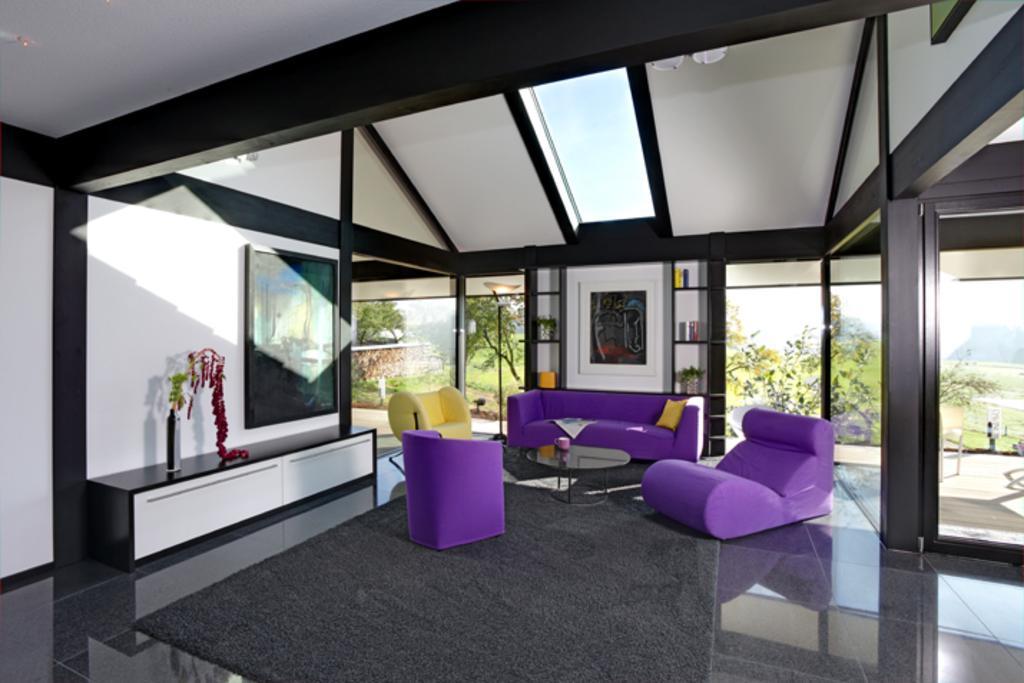Please provide a concise description of this image. In this picture there is a room in which a sofa set is there. There is a photo frame attached to the wall here. In the background there are some windows through which some trees can be observed. 